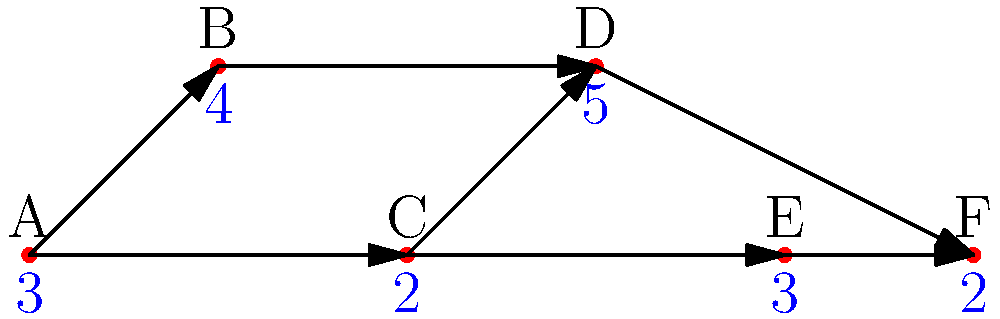Given the network diagram for an IT project, where nodes represent tasks and edges represent dependencies, and the numbers below each node indicate the duration of each task in days, what is the critical path and its total duration? To find the critical path and its duration, we need to follow these steps:

1. Identify all possible paths from start (A) to finish (F):
   Path 1: A → B → D → F
   Path 2: A → C → D → F
   Path 3: A → C → E → F

2. Calculate the duration of each path:
   Path 1: $3 + 4 + 5 + 2 = 14$ days
   Path 2: $3 + 2 + 5 + 2 = 12$ days
   Path 3: $3 + 2 + 3 + 2 = 10$ days

3. The critical path is the longest path through the network, as it represents the minimum time needed to complete the project.

4. Comparing the durations:
   Path 1 (14 days) > Path 2 (12 days) > Path 3 (10 days)

5. Therefore, the critical path is Path 1: A → B → D → F

6. The total duration of the critical path is 14 days.
Answer: Critical path: A → B → D → F; Duration: 14 days 